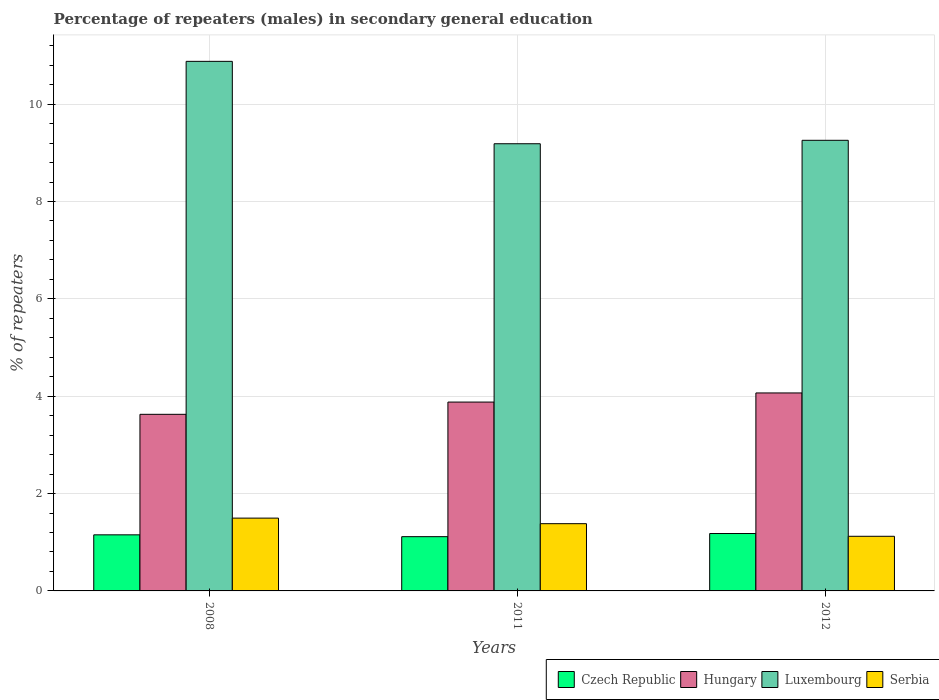Are the number of bars on each tick of the X-axis equal?
Your response must be concise. Yes. How many bars are there on the 2nd tick from the right?
Offer a terse response. 4. What is the label of the 1st group of bars from the left?
Provide a succinct answer. 2008. What is the percentage of male repeaters in Serbia in 2011?
Provide a succinct answer. 1.38. Across all years, what is the maximum percentage of male repeaters in Luxembourg?
Ensure brevity in your answer.  10.88. Across all years, what is the minimum percentage of male repeaters in Czech Republic?
Your response must be concise. 1.11. In which year was the percentage of male repeaters in Hungary maximum?
Offer a very short reply. 2012. What is the total percentage of male repeaters in Hungary in the graph?
Your answer should be compact. 11.58. What is the difference between the percentage of male repeaters in Hungary in 2011 and that in 2012?
Ensure brevity in your answer.  -0.19. What is the difference between the percentage of male repeaters in Czech Republic in 2008 and the percentage of male repeaters in Hungary in 2012?
Make the answer very short. -2.92. What is the average percentage of male repeaters in Hungary per year?
Keep it short and to the point. 3.86. In the year 2008, what is the difference between the percentage of male repeaters in Serbia and percentage of male repeaters in Hungary?
Offer a terse response. -2.13. What is the ratio of the percentage of male repeaters in Hungary in 2011 to that in 2012?
Keep it short and to the point. 0.95. Is the percentage of male repeaters in Luxembourg in 2011 less than that in 2012?
Make the answer very short. Yes. What is the difference between the highest and the second highest percentage of male repeaters in Czech Republic?
Your response must be concise. 0.03. What is the difference between the highest and the lowest percentage of male repeaters in Serbia?
Your answer should be compact. 0.37. In how many years, is the percentage of male repeaters in Hungary greater than the average percentage of male repeaters in Hungary taken over all years?
Your response must be concise. 2. Is it the case that in every year, the sum of the percentage of male repeaters in Luxembourg and percentage of male repeaters in Czech Republic is greater than the sum of percentage of male repeaters in Hungary and percentage of male repeaters in Serbia?
Ensure brevity in your answer.  Yes. What does the 3rd bar from the left in 2011 represents?
Give a very brief answer. Luxembourg. What does the 3rd bar from the right in 2012 represents?
Make the answer very short. Hungary. Are all the bars in the graph horizontal?
Provide a short and direct response. No. How many years are there in the graph?
Make the answer very short. 3. Are the values on the major ticks of Y-axis written in scientific E-notation?
Provide a succinct answer. No. How are the legend labels stacked?
Your answer should be compact. Horizontal. What is the title of the graph?
Your response must be concise. Percentage of repeaters (males) in secondary general education. What is the label or title of the X-axis?
Provide a short and direct response. Years. What is the label or title of the Y-axis?
Provide a short and direct response. % of repeaters. What is the % of repeaters of Czech Republic in 2008?
Make the answer very short. 1.15. What is the % of repeaters in Hungary in 2008?
Make the answer very short. 3.63. What is the % of repeaters of Luxembourg in 2008?
Make the answer very short. 10.88. What is the % of repeaters of Serbia in 2008?
Offer a terse response. 1.5. What is the % of repeaters in Czech Republic in 2011?
Give a very brief answer. 1.11. What is the % of repeaters of Hungary in 2011?
Offer a terse response. 3.88. What is the % of repeaters in Luxembourg in 2011?
Provide a short and direct response. 9.19. What is the % of repeaters of Serbia in 2011?
Offer a very short reply. 1.38. What is the % of repeaters of Czech Republic in 2012?
Offer a terse response. 1.18. What is the % of repeaters in Hungary in 2012?
Keep it short and to the point. 4.07. What is the % of repeaters of Luxembourg in 2012?
Make the answer very short. 9.26. What is the % of repeaters in Serbia in 2012?
Provide a short and direct response. 1.12. Across all years, what is the maximum % of repeaters in Czech Republic?
Provide a short and direct response. 1.18. Across all years, what is the maximum % of repeaters in Hungary?
Keep it short and to the point. 4.07. Across all years, what is the maximum % of repeaters of Luxembourg?
Your answer should be very brief. 10.88. Across all years, what is the maximum % of repeaters in Serbia?
Keep it short and to the point. 1.5. Across all years, what is the minimum % of repeaters in Czech Republic?
Make the answer very short. 1.11. Across all years, what is the minimum % of repeaters in Hungary?
Provide a succinct answer. 3.63. Across all years, what is the minimum % of repeaters in Luxembourg?
Your response must be concise. 9.19. Across all years, what is the minimum % of repeaters in Serbia?
Keep it short and to the point. 1.12. What is the total % of repeaters in Czech Republic in the graph?
Provide a succinct answer. 3.45. What is the total % of repeaters in Hungary in the graph?
Your answer should be very brief. 11.58. What is the total % of repeaters of Luxembourg in the graph?
Provide a succinct answer. 29.32. What is the total % of repeaters of Serbia in the graph?
Your response must be concise. 4. What is the difference between the % of repeaters of Czech Republic in 2008 and that in 2011?
Your response must be concise. 0.04. What is the difference between the % of repeaters in Hungary in 2008 and that in 2011?
Provide a succinct answer. -0.25. What is the difference between the % of repeaters in Luxembourg in 2008 and that in 2011?
Make the answer very short. 1.69. What is the difference between the % of repeaters in Serbia in 2008 and that in 2011?
Make the answer very short. 0.11. What is the difference between the % of repeaters in Czech Republic in 2008 and that in 2012?
Your response must be concise. -0.03. What is the difference between the % of repeaters in Hungary in 2008 and that in 2012?
Provide a short and direct response. -0.44. What is the difference between the % of repeaters in Luxembourg in 2008 and that in 2012?
Provide a succinct answer. 1.62. What is the difference between the % of repeaters in Serbia in 2008 and that in 2012?
Provide a succinct answer. 0.37. What is the difference between the % of repeaters of Czech Republic in 2011 and that in 2012?
Provide a short and direct response. -0.06. What is the difference between the % of repeaters in Hungary in 2011 and that in 2012?
Offer a very short reply. -0.19. What is the difference between the % of repeaters of Luxembourg in 2011 and that in 2012?
Offer a very short reply. -0.07. What is the difference between the % of repeaters in Serbia in 2011 and that in 2012?
Offer a very short reply. 0.26. What is the difference between the % of repeaters in Czech Republic in 2008 and the % of repeaters in Hungary in 2011?
Your answer should be compact. -2.73. What is the difference between the % of repeaters of Czech Republic in 2008 and the % of repeaters of Luxembourg in 2011?
Your answer should be very brief. -8.03. What is the difference between the % of repeaters in Czech Republic in 2008 and the % of repeaters in Serbia in 2011?
Ensure brevity in your answer.  -0.23. What is the difference between the % of repeaters in Hungary in 2008 and the % of repeaters in Luxembourg in 2011?
Offer a very short reply. -5.56. What is the difference between the % of repeaters of Hungary in 2008 and the % of repeaters of Serbia in 2011?
Your answer should be compact. 2.25. What is the difference between the % of repeaters in Luxembourg in 2008 and the % of repeaters in Serbia in 2011?
Your answer should be compact. 9.5. What is the difference between the % of repeaters of Czech Republic in 2008 and the % of repeaters of Hungary in 2012?
Your answer should be very brief. -2.92. What is the difference between the % of repeaters in Czech Republic in 2008 and the % of repeaters in Luxembourg in 2012?
Ensure brevity in your answer.  -8.11. What is the difference between the % of repeaters in Czech Republic in 2008 and the % of repeaters in Serbia in 2012?
Your answer should be compact. 0.03. What is the difference between the % of repeaters of Hungary in 2008 and the % of repeaters of Luxembourg in 2012?
Your answer should be compact. -5.63. What is the difference between the % of repeaters of Hungary in 2008 and the % of repeaters of Serbia in 2012?
Keep it short and to the point. 2.51. What is the difference between the % of repeaters in Luxembourg in 2008 and the % of repeaters in Serbia in 2012?
Offer a very short reply. 9.76. What is the difference between the % of repeaters of Czech Republic in 2011 and the % of repeaters of Hungary in 2012?
Ensure brevity in your answer.  -2.95. What is the difference between the % of repeaters in Czech Republic in 2011 and the % of repeaters in Luxembourg in 2012?
Ensure brevity in your answer.  -8.14. What is the difference between the % of repeaters of Czech Republic in 2011 and the % of repeaters of Serbia in 2012?
Offer a terse response. -0.01. What is the difference between the % of repeaters of Hungary in 2011 and the % of repeaters of Luxembourg in 2012?
Provide a succinct answer. -5.38. What is the difference between the % of repeaters of Hungary in 2011 and the % of repeaters of Serbia in 2012?
Your answer should be very brief. 2.76. What is the difference between the % of repeaters of Luxembourg in 2011 and the % of repeaters of Serbia in 2012?
Offer a very short reply. 8.06. What is the average % of repeaters in Czech Republic per year?
Keep it short and to the point. 1.15. What is the average % of repeaters in Hungary per year?
Your answer should be very brief. 3.86. What is the average % of repeaters of Luxembourg per year?
Your answer should be very brief. 9.77. What is the average % of repeaters in Serbia per year?
Make the answer very short. 1.33. In the year 2008, what is the difference between the % of repeaters in Czech Republic and % of repeaters in Hungary?
Offer a terse response. -2.48. In the year 2008, what is the difference between the % of repeaters in Czech Republic and % of repeaters in Luxembourg?
Offer a terse response. -9.73. In the year 2008, what is the difference between the % of repeaters of Czech Republic and % of repeaters of Serbia?
Provide a succinct answer. -0.34. In the year 2008, what is the difference between the % of repeaters of Hungary and % of repeaters of Luxembourg?
Your answer should be very brief. -7.25. In the year 2008, what is the difference between the % of repeaters in Hungary and % of repeaters in Serbia?
Provide a succinct answer. 2.13. In the year 2008, what is the difference between the % of repeaters in Luxembourg and % of repeaters in Serbia?
Provide a succinct answer. 9.38. In the year 2011, what is the difference between the % of repeaters of Czech Republic and % of repeaters of Hungary?
Offer a very short reply. -2.77. In the year 2011, what is the difference between the % of repeaters in Czech Republic and % of repeaters in Luxembourg?
Offer a very short reply. -8.07. In the year 2011, what is the difference between the % of repeaters of Czech Republic and % of repeaters of Serbia?
Your response must be concise. -0.27. In the year 2011, what is the difference between the % of repeaters of Hungary and % of repeaters of Luxembourg?
Offer a very short reply. -5.31. In the year 2011, what is the difference between the % of repeaters of Hungary and % of repeaters of Serbia?
Give a very brief answer. 2.5. In the year 2011, what is the difference between the % of repeaters in Luxembourg and % of repeaters in Serbia?
Provide a succinct answer. 7.81. In the year 2012, what is the difference between the % of repeaters of Czech Republic and % of repeaters of Hungary?
Make the answer very short. -2.89. In the year 2012, what is the difference between the % of repeaters in Czech Republic and % of repeaters in Luxembourg?
Ensure brevity in your answer.  -8.08. In the year 2012, what is the difference between the % of repeaters of Czech Republic and % of repeaters of Serbia?
Make the answer very short. 0.06. In the year 2012, what is the difference between the % of repeaters in Hungary and % of repeaters in Luxembourg?
Keep it short and to the point. -5.19. In the year 2012, what is the difference between the % of repeaters in Hungary and % of repeaters in Serbia?
Give a very brief answer. 2.95. In the year 2012, what is the difference between the % of repeaters in Luxembourg and % of repeaters in Serbia?
Your answer should be very brief. 8.14. What is the ratio of the % of repeaters in Czech Republic in 2008 to that in 2011?
Keep it short and to the point. 1.03. What is the ratio of the % of repeaters of Hungary in 2008 to that in 2011?
Give a very brief answer. 0.94. What is the ratio of the % of repeaters of Luxembourg in 2008 to that in 2011?
Provide a succinct answer. 1.18. What is the ratio of the % of repeaters of Serbia in 2008 to that in 2011?
Provide a succinct answer. 1.08. What is the ratio of the % of repeaters of Czech Republic in 2008 to that in 2012?
Offer a very short reply. 0.98. What is the ratio of the % of repeaters of Hungary in 2008 to that in 2012?
Make the answer very short. 0.89. What is the ratio of the % of repeaters in Luxembourg in 2008 to that in 2012?
Make the answer very short. 1.18. What is the ratio of the % of repeaters of Serbia in 2008 to that in 2012?
Your answer should be very brief. 1.33. What is the ratio of the % of repeaters in Czech Republic in 2011 to that in 2012?
Provide a succinct answer. 0.95. What is the ratio of the % of repeaters of Hungary in 2011 to that in 2012?
Offer a very short reply. 0.95. What is the ratio of the % of repeaters in Serbia in 2011 to that in 2012?
Offer a terse response. 1.23. What is the difference between the highest and the second highest % of repeaters in Czech Republic?
Your answer should be compact. 0.03. What is the difference between the highest and the second highest % of repeaters in Hungary?
Offer a terse response. 0.19. What is the difference between the highest and the second highest % of repeaters in Luxembourg?
Your answer should be very brief. 1.62. What is the difference between the highest and the second highest % of repeaters in Serbia?
Your answer should be compact. 0.11. What is the difference between the highest and the lowest % of repeaters of Czech Republic?
Offer a terse response. 0.06. What is the difference between the highest and the lowest % of repeaters in Hungary?
Provide a succinct answer. 0.44. What is the difference between the highest and the lowest % of repeaters in Luxembourg?
Your answer should be very brief. 1.69. What is the difference between the highest and the lowest % of repeaters in Serbia?
Give a very brief answer. 0.37. 